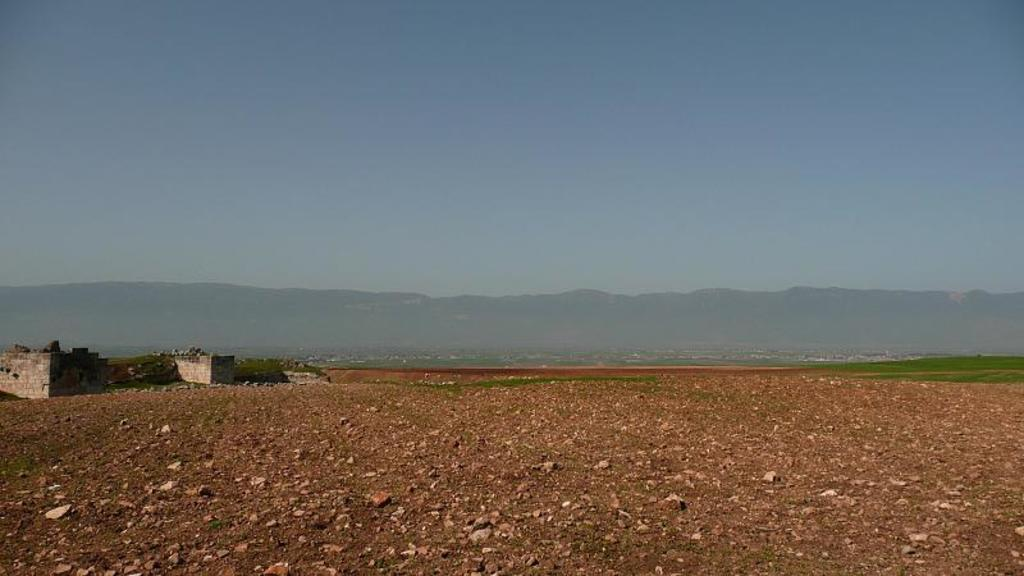What type of structure can be seen in the image? There is a stone construction in the image. What natural feature is visible in the image? There is a hill in the image. What type of vegetation is present in the image? Grass is present in the image. What is visible in the background of the image? The sky is visible in the image. What type of silk material is draped over the stone construction in the image? There is no silk material present in the image; it features a stone construction, a hill, grass, and the sky. Can you see a bear interacting with the stone construction in the image? There is no bear present in the image; it only features a stone construction, a hill, grass, and the sky. 